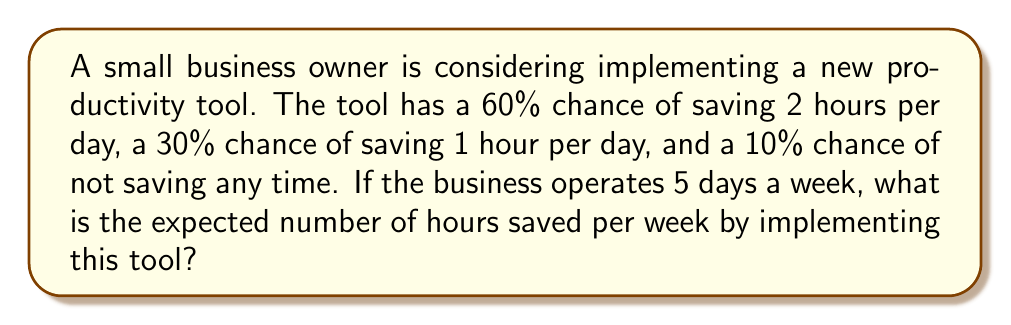Provide a solution to this math problem. Let's approach this step-by-step:

1) First, let's define our random variable X as the number of hours saved per day.

2) We can create a probability distribution for X:
   P(X = 2) = 0.60
   P(X = 1) = 0.30
   P(X = 0) = 0.10

3) The expected value of X, E(X), is calculated as:
   
   $$E(X) = \sum_{i} x_i \cdot P(X = x_i)$$

4) Substituting our values:
   
   $$E(X) = 2 \cdot 0.60 + 1 \cdot 0.30 + 0 \cdot 0.10$$

5) Calculating:
   
   $$E(X) = 1.2 + 0.3 + 0 = 1.5$$

6) So, the expected number of hours saved per day is 1.5 hours.

7) To find the expected number of hours saved per week, we multiply by 5 (as the business operates 5 days a week):
   
   $$E(\text{hours saved per week}) = 1.5 \cdot 5 = 7.5$$

Therefore, the expected number of hours saved per week is 7.5 hours.
Answer: 7.5 hours 